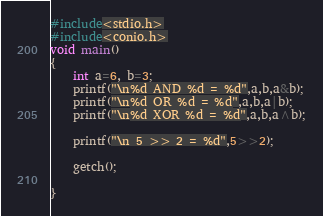Convert code to text. <code><loc_0><loc_0><loc_500><loc_500><_C_>#include<stdio.h>
#include<conio.h>
void main()
{
    int a=6, b=3;
    printf("\n%d AND %d = %d",a,b,a&b);
    printf("\n%d OR %d = %d",a,b,a|b);
    printf("\n%d XOR %d = %d",a,b,a^b);

    printf("\n 5 >> 2 = %d",5>>2);

    getch();

}
</code> 